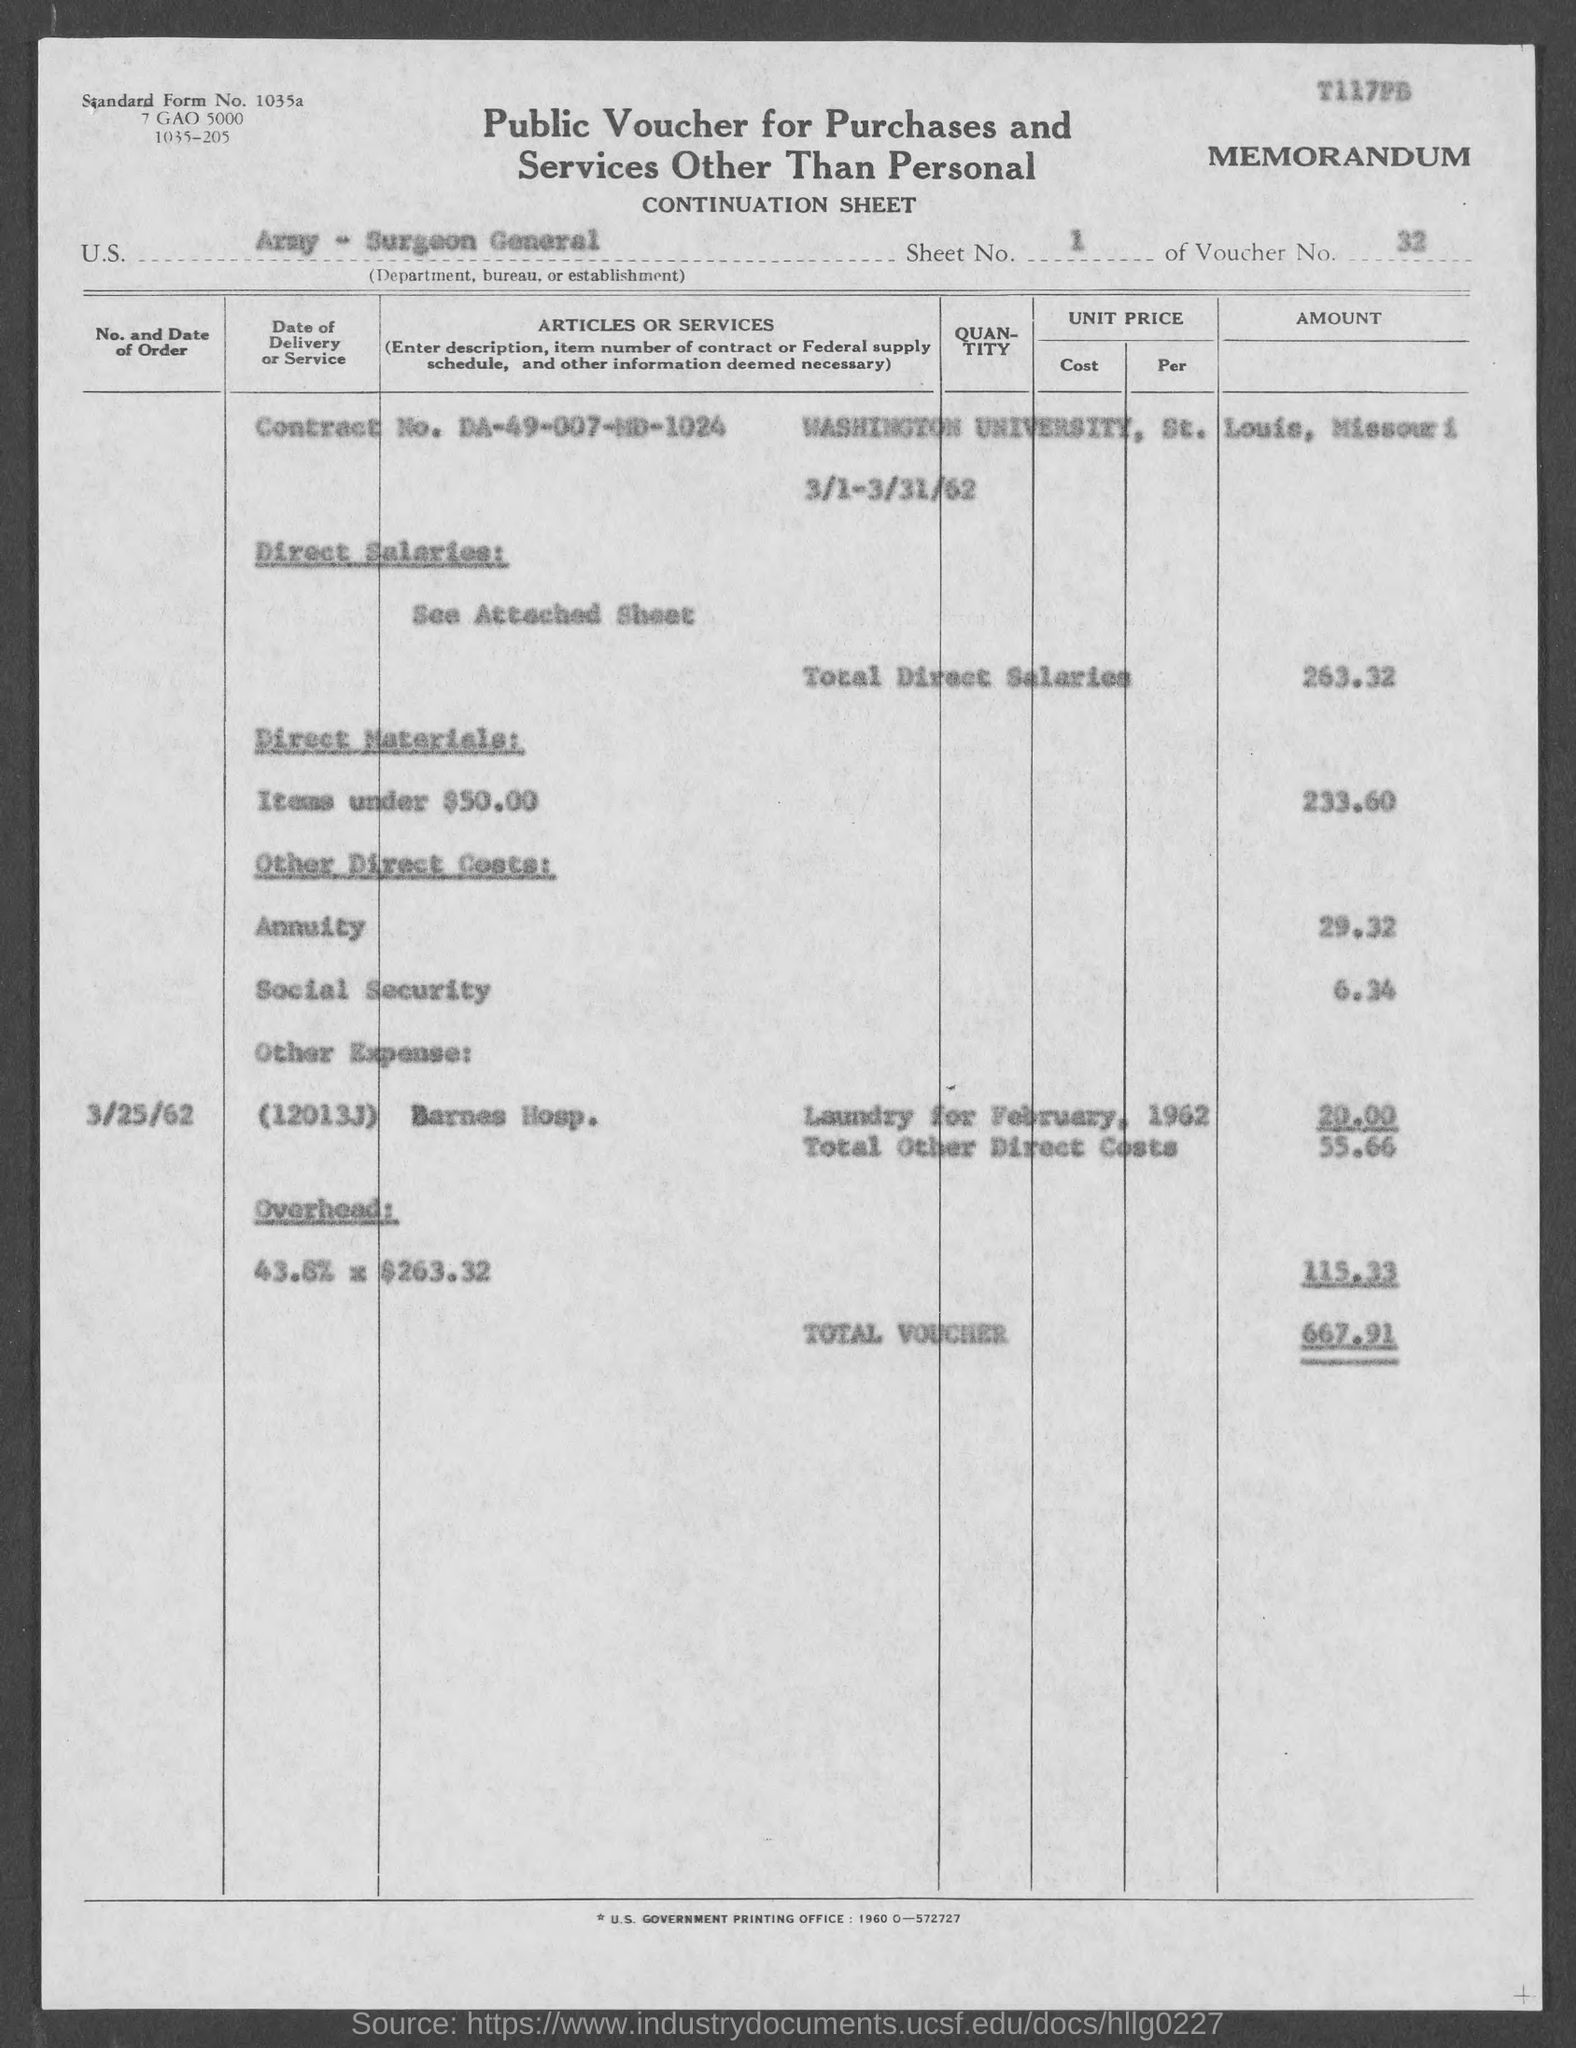What is the significance of the date range listed on the document? The date range from 3/1/62 to 3/31/62 indicates that the charges and transactions listed on the voucher relate to services rendered or products delivered within that month. This might have been a standard billing or reporting period for the financial operations of the U.S. Army Surgeon General's department. 